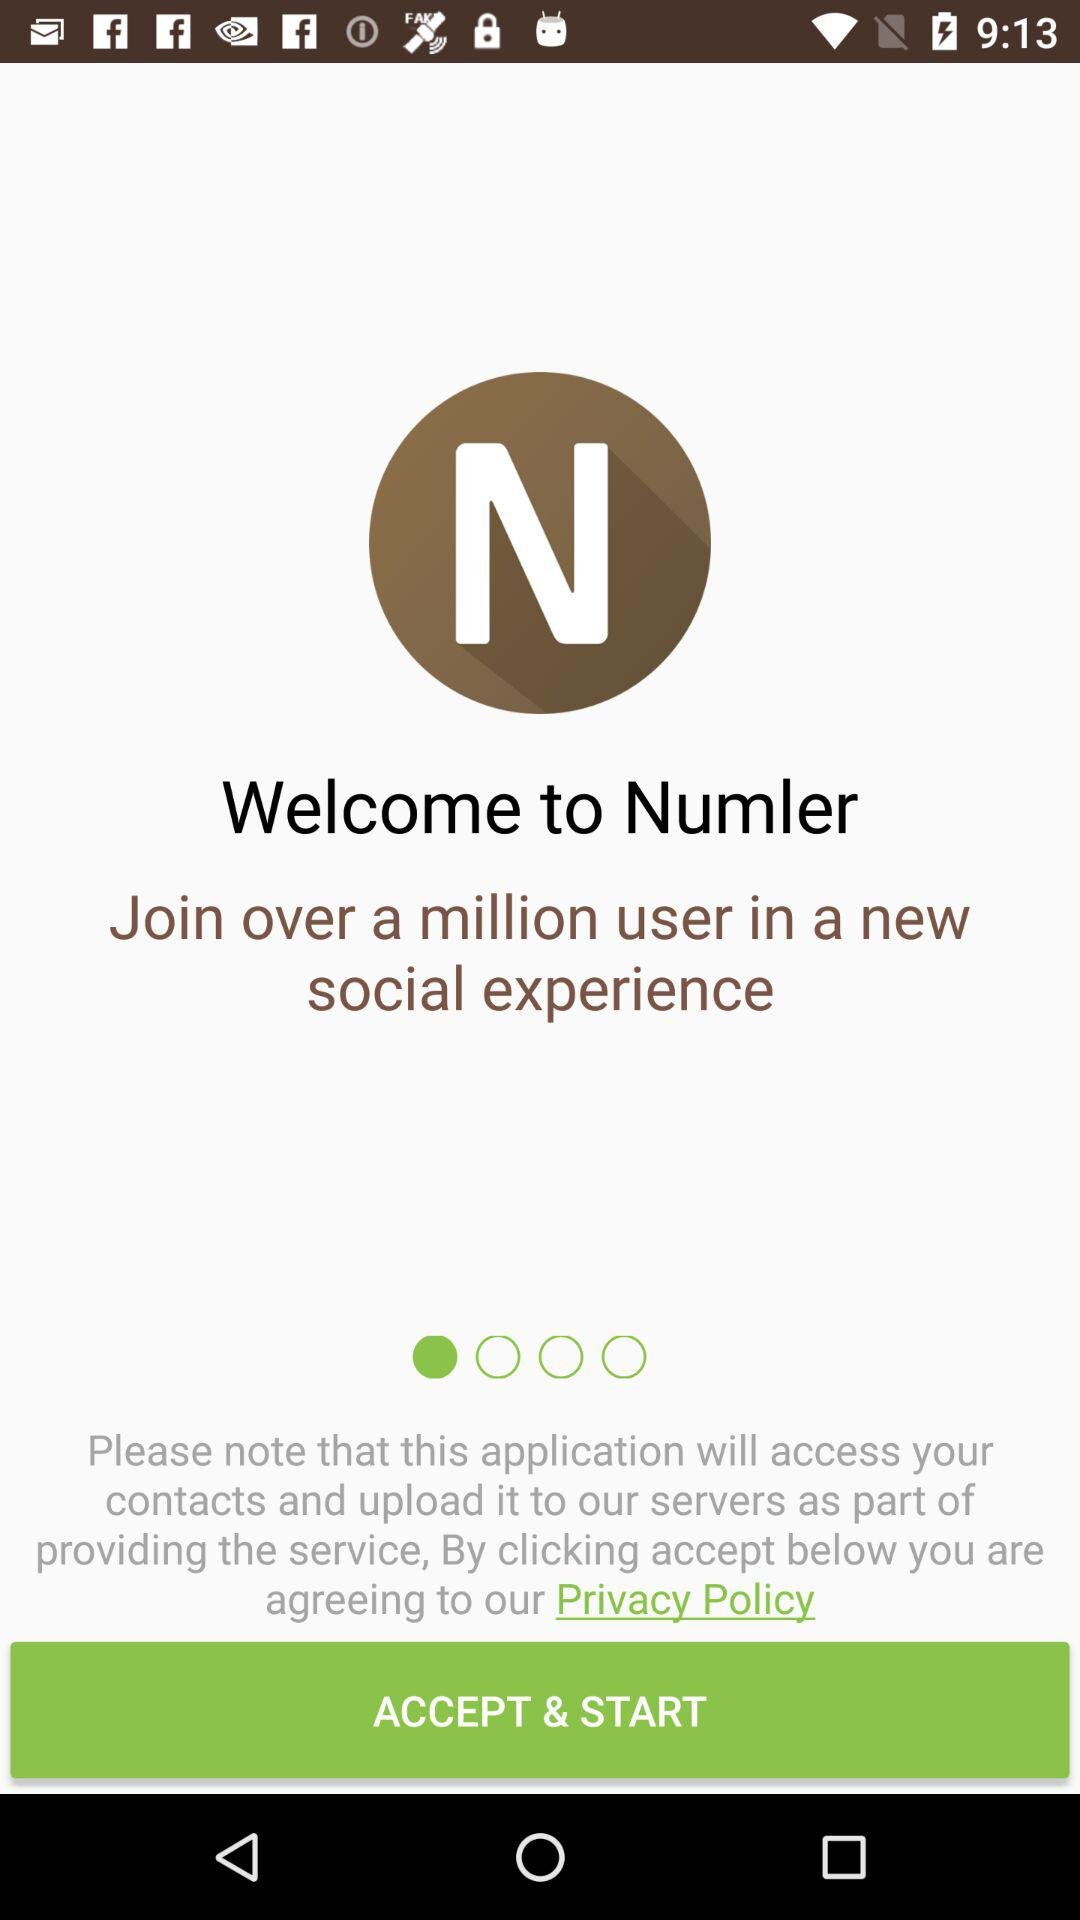What is the name of the application? The name of the application is "Numler". 